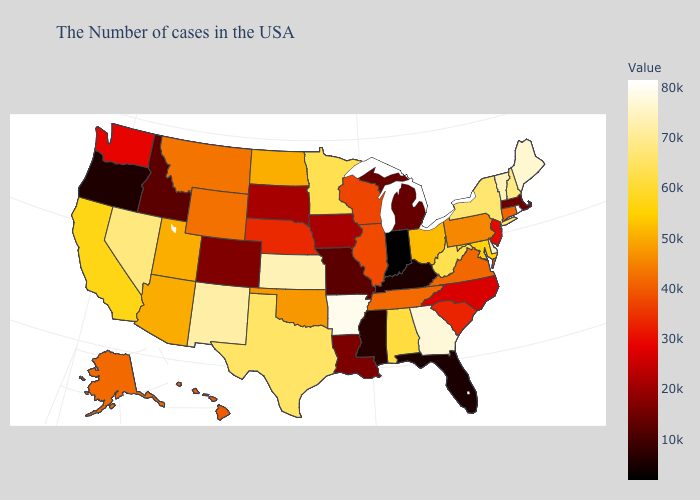Which states have the lowest value in the Northeast?
Answer briefly. Massachusetts. Is the legend a continuous bar?
Short answer required. Yes. Does Florida have the lowest value in the South?
Short answer required. Yes. 